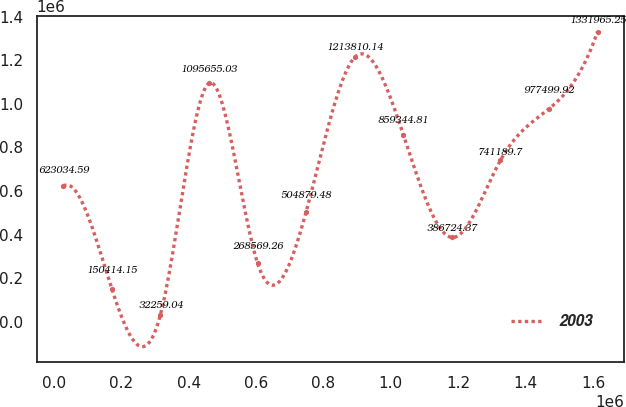Convert chart. <chart><loc_0><loc_0><loc_500><loc_500><line_chart><ecel><fcel>2003<nl><fcel>28066<fcel>623035<nl><fcel>172209<fcel>150414<nl><fcel>316352<fcel>32259<nl><fcel>460494<fcel>1.09566e+06<nl><fcel>604637<fcel>268569<nl><fcel>748780<fcel>504879<nl><fcel>892922<fcel>1.21381e+06<nl><fcel>1.03707e+06<fcel>859345<nl><fcel>1.18121e+06<fcel>386724<nl><fcel>1.32535e+06<fcel>741190<nl><fcel>1.46949e+06<fcel>977500<nl><fcel>1.61364e+06<fcel>1.33197e+06<nl></chart> 